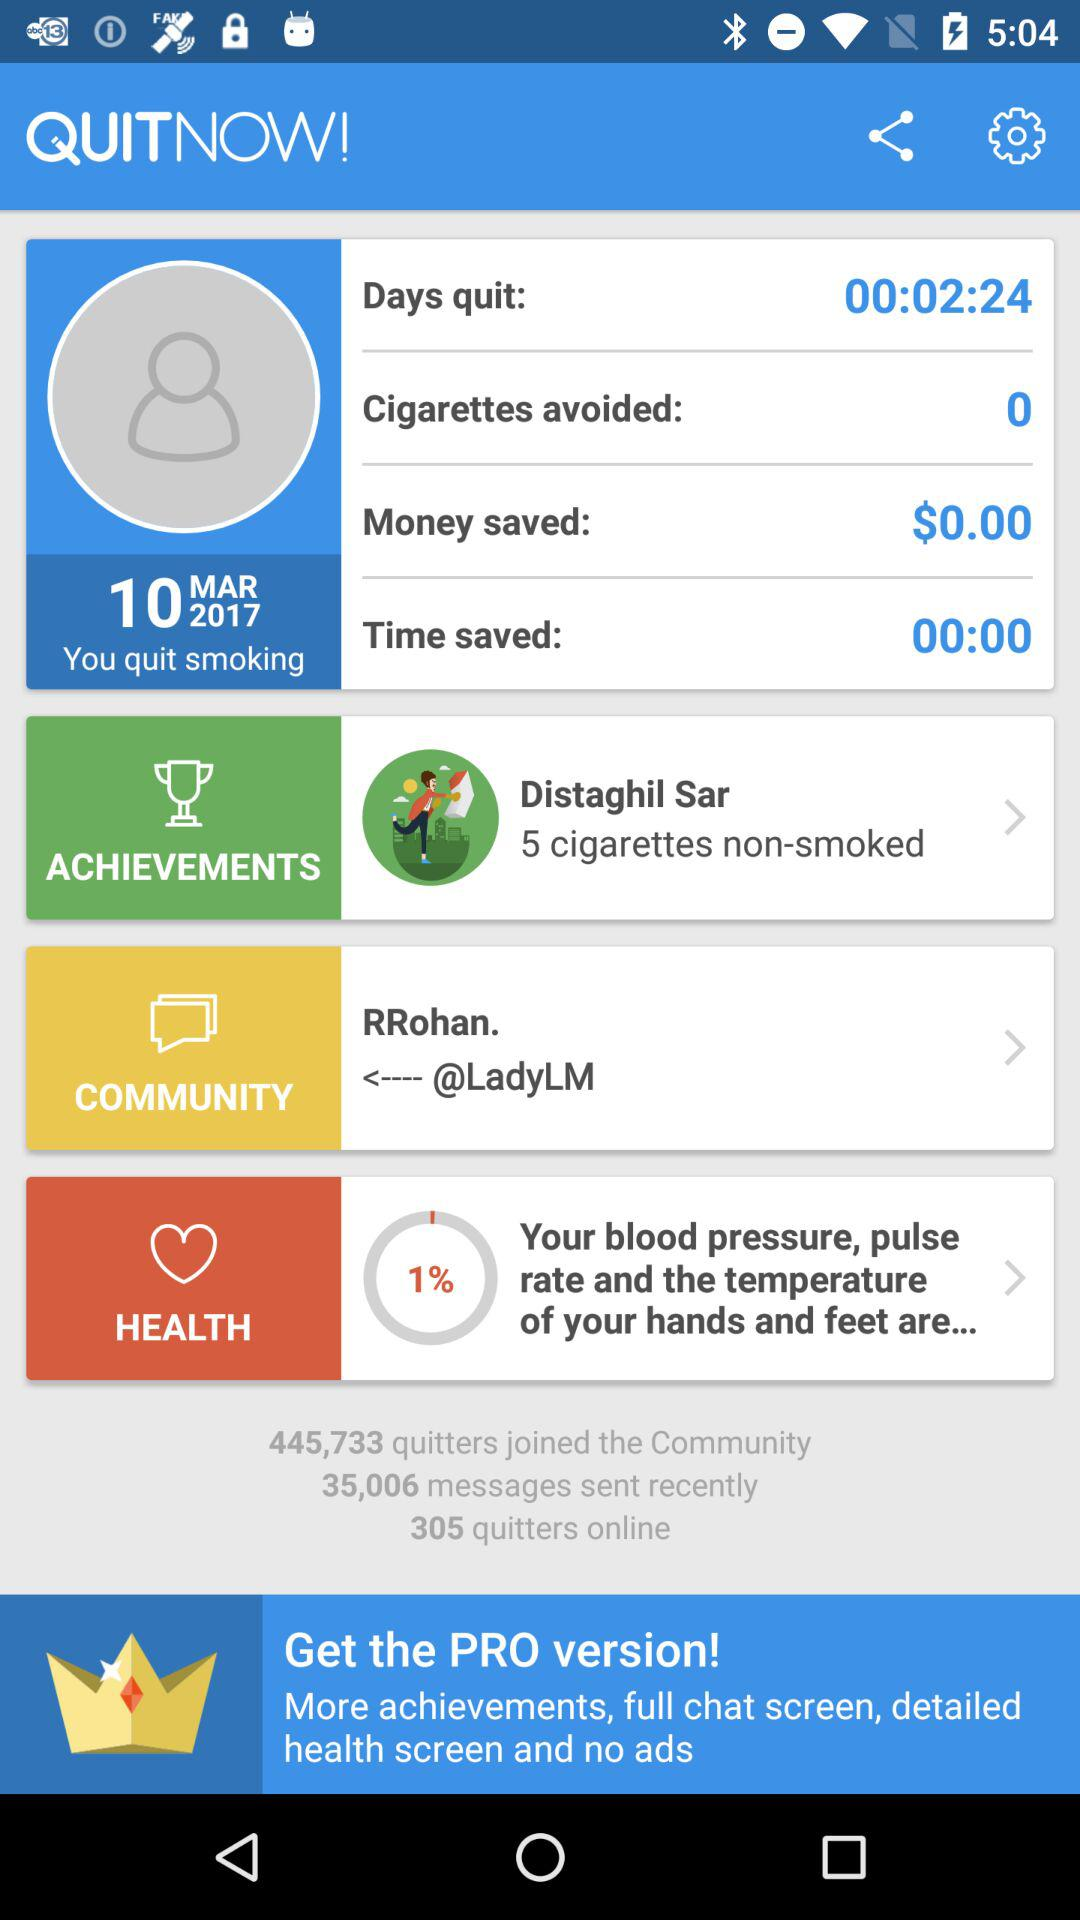How many quitters are there online? There are 305 quitters online. 